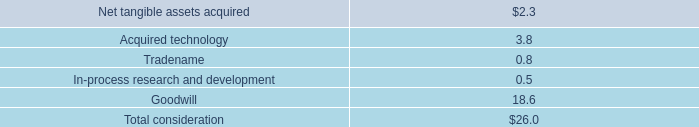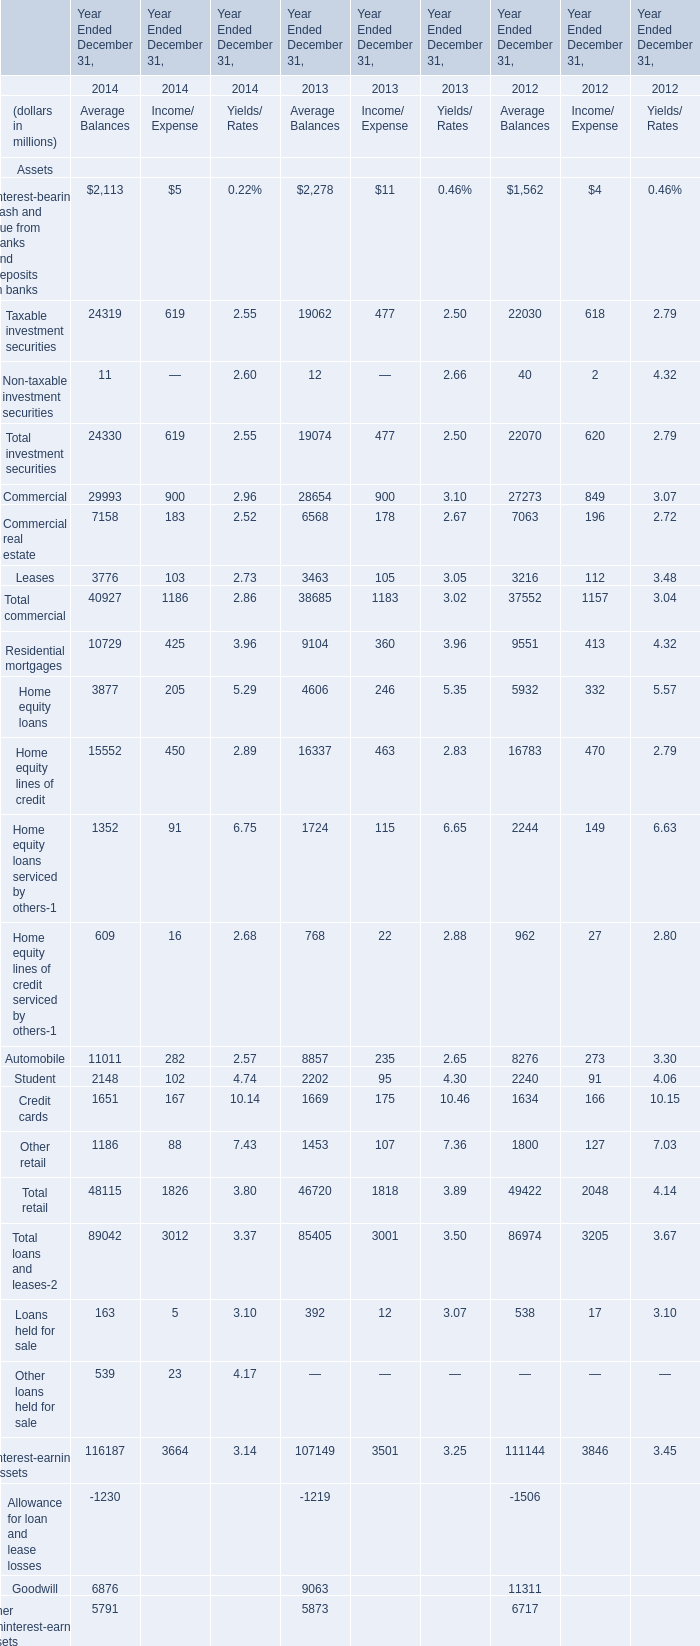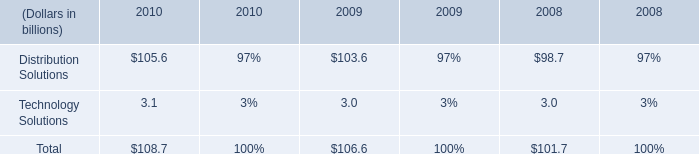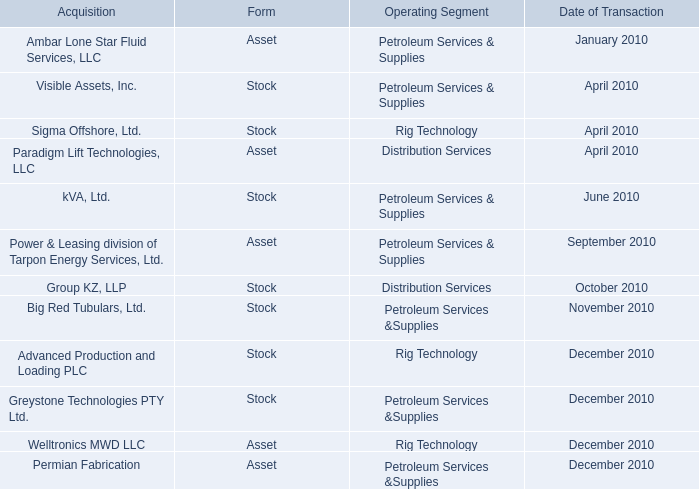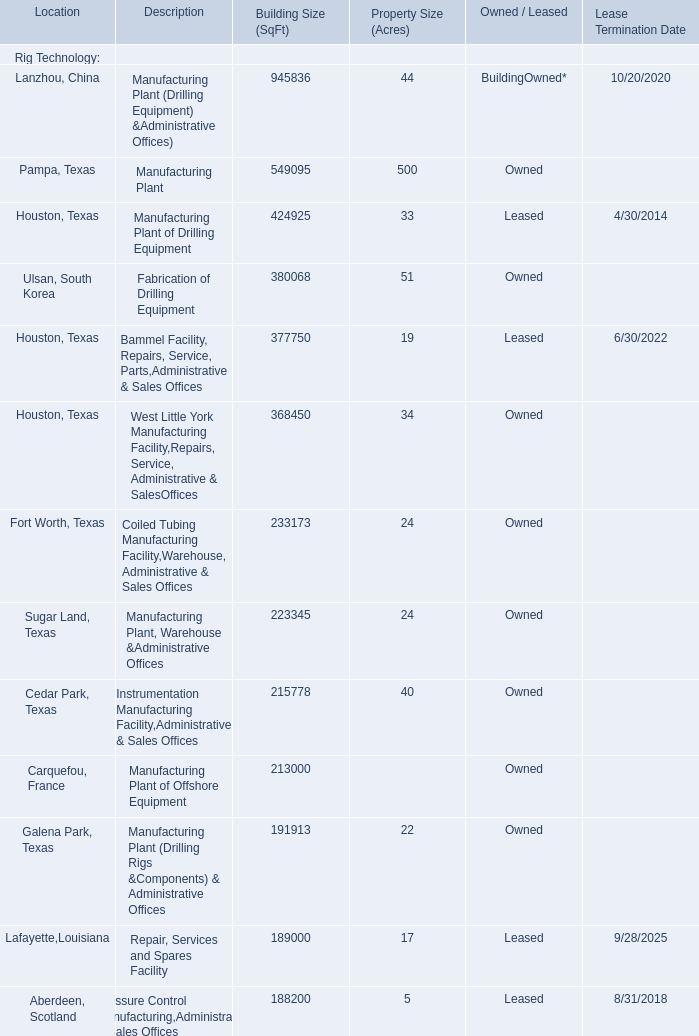When does Taxable investment securities reach the largest value? 
Answer: 2014. 